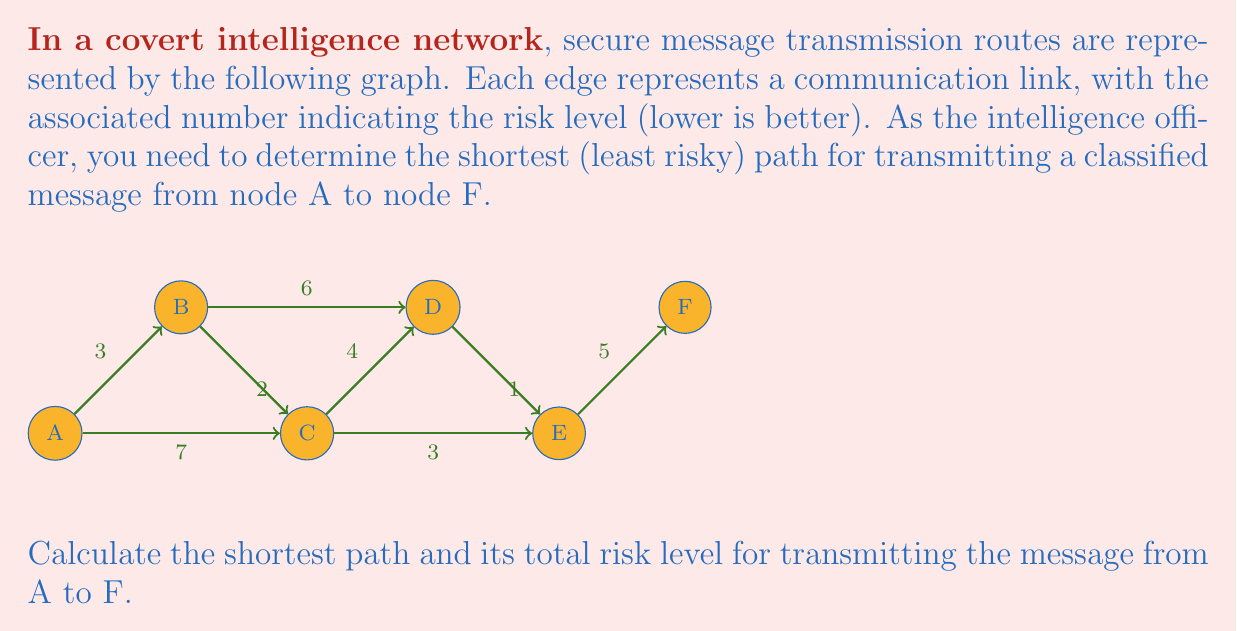Teach me how to tackle this problem. To solve this problem, we'll use Dijkstra's algorithm, which is optimal for finding the shortest path in a weighted graph.

Step 1: Initialize distances
Set distance to A as 0, and all other nodes as infinity.
$d(A) = 0$, $d(B) = d(C) = d(D) = d(E) = d(F) = \infty$

Step 2: Visit node A
Update neighbors of A:
$d(B) = \min(\infty, 0 + 3) = 3$
$d(C) = \min(\infty, 0 + 7) = 7$

Step 3: Visit node B (closest unvisited)
Update neighbors of B:
$d(C) = \min(7, 3 + 2) = 5$
$d(D) = \min(\infty, 3 + 6) = 9$

Step 4: Visit node C
Update neighbors of C:
$d(D) = \min(9, 5 + 4) = 9$
$d(E) = \min(\infty, 5 + 3) = 8$

Step 5: Visit node E
Update neighbors of E:
$d(F) = \min(\infty, 8 + 5) = 13$

Step 6: Visit node D
No updates (all neighbors visited or longer path)

Step 7: Visit node F
Algorithm complete, shortest path found

The shortest path is A → B → C → E → F with a total risk level of 13.
Answer: A → B → C → E → F, risk level 13 